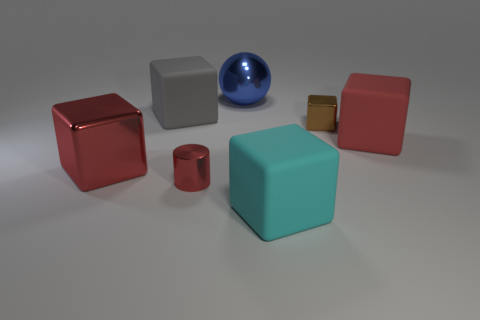There is a large thing that is behind the brown metallic block and in front of the large blue metallic ball; what is its color?
Your answer should be compact. Gray. The metal object that is the same color as the large metal cube is what size?
Ensure brevity in your answer.  Small. How many small objects are metal objects or red objects?
Offer a terse response. 2. Are there any other things that have the same color as the tiny metallic cylinder?
Give a very brief answer. Yes. The big red block right of the small object behind the large red thing on the right side of the small brown thing is made of what material?
Offer a terse response. Rubber. What number of matte objects are tiny things or balls?
Offer a terse response. 0. How many red objects are rubber cubes or big shiny things?
Provide a succinct answer. 2. There is a cube to the left of the big gray rubber thing; is it the same color as the tiny shiny cylinder?
Give a very brief answer. Yes. Are the brown block and the ball made of the same material?
Your answer should be very brief. Yes. Is the number of blue metal spheres that are in front of the brown object the same as the number of large cyan rubber objects behind the cyan matte thing?
Offer a very short reply. Yes. 